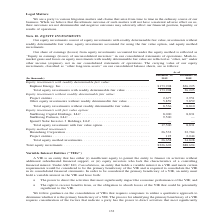According to Sunpower Corporation's financial document, What does the company's equity investments consist of? Consist of equity investments with readily determinable fair value, investments without readily determinable fair value, equity investments accounted for using the fair value option, and equity method investments.. The document states: "Our equity investments consist of equity investments with readily determinable fair value, investments without readily determinable fair value, equity..." Also, What is the share of earnings from equity investments accounted for under the equity method reflected as? ‘‘Equity in earnings (losses) of unconsolidated investees’’ in our consolidated statements of operations. The document states: "ounted for under the equity method is reflected as ‘‘Equity in earnings (losses) of unconsolidated investees’’ in our consolidated statements of opera..." Also, In which years is equity investments recorded for? The document shows two values: 2019 and 2018. From the document: "(In thousands) December 29, 2019 December 30, 2018 (In thousands) December 29, 2019 December 30, 2018..." Additionally, Which year is the total equity investment with fair value option higher? According to the financial document, 2019. The relevant text states: "(In thousands) December 29, 2019 December 30, 2018..." Also, can you calculate: What was the change in total equity method investments from 2018 to 2019? Based on the calculation: 26,658 - 34,828 , the result is -8170 (in thousands). This is based on the information: "Total equity method investments. . 26,658 34,828 Total equity method investments. . 26,658 34,828..." The key data points involved are: 26,658, 34,828. Also, can you calculate: What was the percentage change in total equity investments from 2018 to 2019? To answer this question, I need to perform calculations using the financial data. The calculation is: ($226,602 - $88,694)/$88,694 , which equals 155.49 (percentage). This is based on the information: "Total equity investments . $226,602 $88,694 Total equity investments . $226,602 $88,694..." The key data points involved are: 226,602, 88,694. 